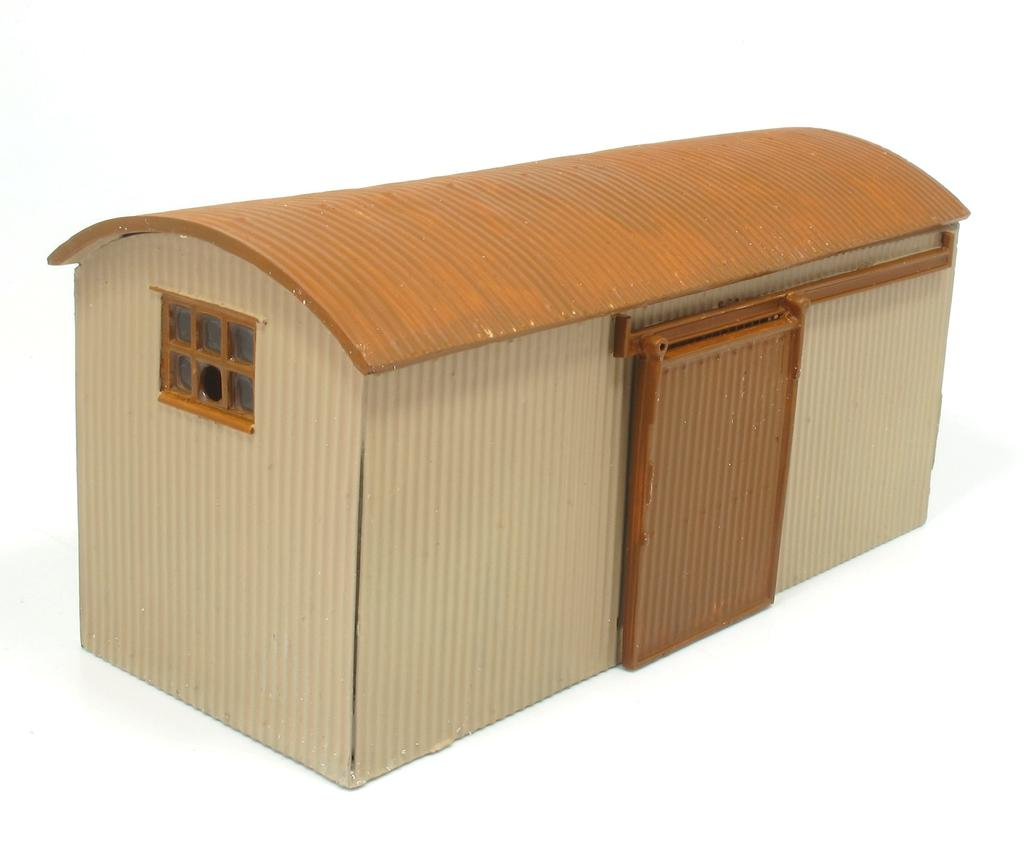What is the main structure in the middle of the image? There is a shelter in the middle of the image. What features does the shelter have? The shelter has a door, a roof, and a window. What color is the background of the image? The background of the image is white in color. Can you tell me how many cows are wearing jeans inside the shelter? There are no cows or jeans present in the picture; it features a shelter with a door, roof, and window against a white background. 